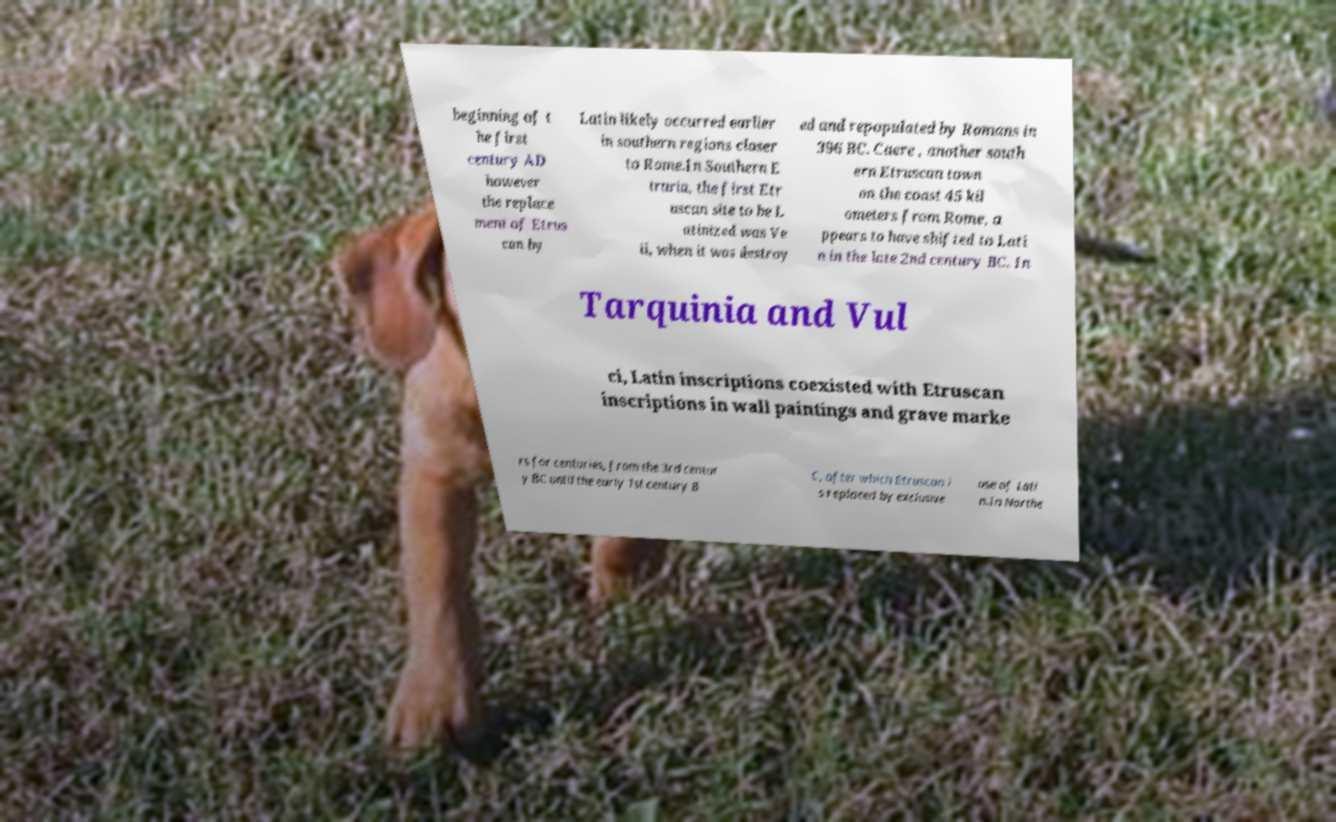Can you accurately transcribe the text from the provided image for me? beginning of t he first century AD however the replace ment of Etrus can by Latin likely occurred earlier in southern regions closer to Rome.In Southern E truria, the first Etr uscan site to be L atinized was Ve ii, when it was destroy ed and repopulated by Romans in 396 BC. Caere , another south ern Etruscan town on the coast 45 kil ometers from Rome, a ppears to have shifted to Lati n in the late 2nd century BC. In Tarquinia and Vul ci, Latin inscriptions coexisted with Etruscan inscriptions in wall paintings and grave marke rs for centuries, from the 3rd centur y BC until the early 1st century B C, after which Etruscan i s replaced by exclusive use of Lati n.In Northe 